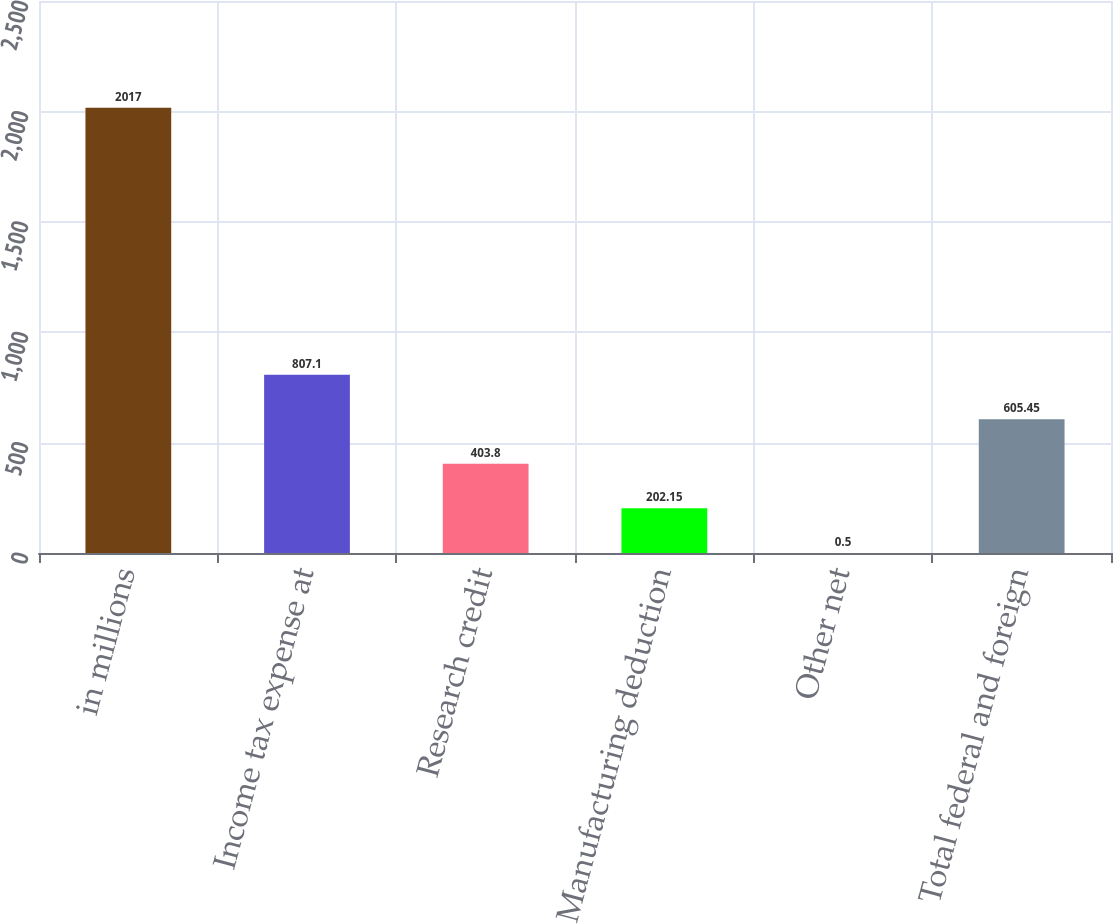<chart> <loc_0><loc_0><loc_500><loc_500><bar_chart><fcel>in millions<fcel>Income tax expense at<fcel>Research credit<fcel>Manufacturing deduction<fcel>Other net<fcel>Total federal and foreign<nl><fcel>2017<fcel>807.1<fcel>403.8<fcel>202.15<fcel>0.5<fcel>605.45<nl></chart> 